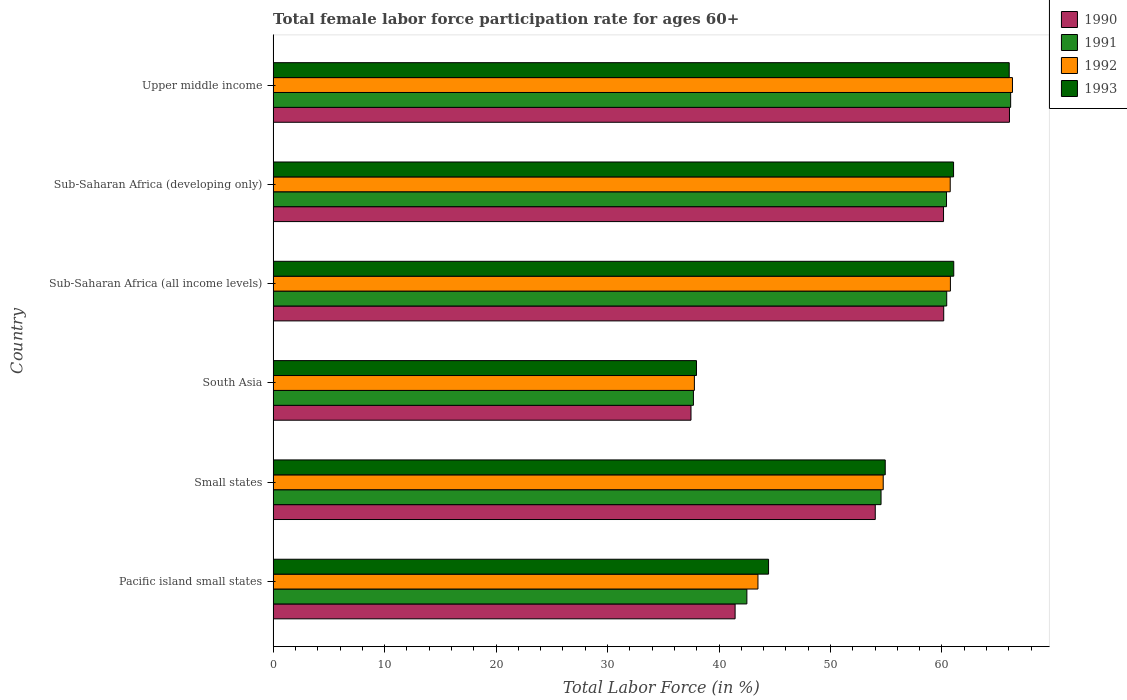How many different coloured bars are there?
Make the answer very short. 4. Are the number of bars per tick equal to the number of legend labels?
Provide a short and direct response. Yes. How many bars are there on the 2nd tick from the bottom?
Keep it short and to the point. 4. What is the label of the 1st group of bars from the top?
Give a very brief answer. Upper middle income. What is the female labor force participation rate in 1993 in South Asia?
Ensure brevity in your answer.  37.98. Across all countries, what is the maximum female labor force participation rate in 1990?
Ensure brevity in your answer.  66.05. Across all countries, what is the minimum female labor force participation rate in 1993?
Offer a terse response. 37.98. In which country was the female labor force participation rate in 1991 maximum?
Provide a short and direct response. Upper middle income. What is the total female labor force participation rate in 1992 in the graph?
Ensure brevity in your answer.  323.83. What is the difference between the female labor force participation rate in 1992 in Sub-Saharan Africa (developing only) and that in Upper middle income?
Keep it short and to the point. -5.58. What is the difference between the female labor force participation rate in 1992 in Pacific island small states and the female labor force participation rate in 1993 in South Asia?
Your answer should be compact. 5.51. What is the average female labor force participation rate in 1993 per country?
Give a very brief answer. 54.24. What is the difference between the female labor force participation rate in 1990 and female labor force participation rate in 1992 in Pacific island small states?
Your response must be concise. -2.05. What is the ratio of the female labor force participation rate in 1990 in Pacific island small states to that in Small states?
Keep it short and to the point. 0.77. Is the female labor force participation rate in 1991 in Sub-Saharan Africa (developing only) less than that in Upper middle income?
Your response must be concise. Yes. Is the difference between the female labor force participation rate in 1990 in Pacific island small states and South Asia greater than the difference between the female labor force participation rate in 1992 in Pacific island small states and South Asia?
Give a very brief answer. No. What is the difference between the highest and the second highest female labor force participation rate in 1991?
Your answer should be very brief. 5.74. What is the difference between the highest and the lowest female labor force participation rate in 1991?
Ensure brevity in your answer.  28.46. In how many countries, is the female labor force participation rate in 1993 greater than the average female labor force participation rate in 1993 taken over all countries?
Provide a succinct answer. 4. Is the sum of the female labor force participation rate in 1992 in Sub-Saharan Africa (all income levels) and Sub-Saharan Africa (developing only) greater than the maximum female labor force participation rate in 1991 across all countries?
Give a very brief answer. Yes. What does the 1st bar from the bottom in Sub-Saharan Africa (developing only) represents?
Give a very brief answer. 1990. Is it the case that in every country, the sum of the female labor force participation rate in 1991 and female labor force participation rate in 1993 is greater than the female labor force participation rate in 1992?
Provide a short and direct response. Yes. How many countries are there in the graph?
Provide a succinct answer. 6. What is the difference between two consecutive major ticks on the X-axis?
Keep it short and to the point. 10. Are the values on the major ticks of X-axis written in scientific E-notation?
Offer a terse response. No. Does the graph contain grids?
Offer a terse response. No. Where does the legend appear in the graph?
Give a very brief answer. Top right. How many legend labels are there?
Keep it short and to the point. 4. What is the title of the graph?
Give a very brief answer. Total female labor force participation rate for ages 60+. What is the Total Labor Force (in %) of 1990 in Pacific island small states?
Offer a very short reply. 41.44. What is the Total Labor Force (in %) in 1991 in Pacific island small states?
Give a very brief answer. 42.5. What is the Total Labor Force (in %) of 1992 in Pacific island small states?
Keep it short and to the point. 43.49. What is the Total Labor Force (in %) in 1993 in Pacific island small states?
Provide a succinct answer. 44.44. What is the Total Labor Force (in %) in 1990 in Small states?
Give a very brief answer. 54.02. What is the Total Labor Force (in %) in 1991 in Small states?
Your answer should be very brief. 54.53. What is the Total Labor Force (in %) of 1992 in Small states?
Ensure brevity in your answer.  54.73. What is the Total Labor Force (in %) of 1993 in Small states?
Your answer should be very brief. 54.91. What is the Total Labor Force (in %) of 1990 in South Asia?
Your answer should be compact. 37.49. What is the Total Labor Force (in %) of 1991 in South Asia?
Offer a very short reply. 37.7. What is the Total Labor Force (in %) in 1992 in South Asia?
Your answer should be very brief. 37.79. What is the Total Labor Force (in %) of 1993 in South Asia?
Your response must be concise. 37.98. What is the Total Labor Force (in %) of 1990 in Sub-Saharan Africa (all income levels)?
Provide a short and direct response. 60.16. What is the Total Labor Force (in %) in 1991 in Sub-Saharan Africa (all income levels)?
Provide a succinct answer. 60.42. What is the Total Labor Force (in %) of 1992 in Sub-Saharan Africa (all income levels)?
Provide a short and direct response. 60.76. What is the Total Labor Force (in %) in 1993 in Sub-Saharan Africa (all income levels)?
Give a very brief answer. 61.06. What is the Total Labor Force (in %) of 1990 in Sub-Saharan Africa (developing only)?
Offer a terse response. 60.14. What is the Total Labor Force (in %) in 1991 in Sub-Saharan Africa (developing only)?
Give a very brief answer. 60.41. What is the Total Labor Force (in %) of 1992 in Sub-Saharan Africa (developing only)?
Offer a very short reply. 60.74. What is the Total Labor Force (in %) in 1993 in Sub-Saharan Africa (developing only)?
Keep it short and to the point. 61.04. What is the Total Labor Force (in %) in 1990 in Upper middle income?
Provide a short and direct response. 66.05. What is the Total Labor Force (in %) of 1991 in Upper middle income?
Your answer should be very brief. 66.16. What is the Total Labor Force (in %) in 1992 in Upper middle income?
Make the answer very short. 66.32. What is the Total Labor Force (in %) of 1993 in Upper middle income?
Ensure brevity in your answer.  66.03. Across all countries, what is the maximum Total Labor Force (in %) of 1990?
Ensure brevity in your answer.  66.05. Across all countries, what is the maximum Total Labor Force (in %) of 1991?
Provide a short and direct response. 66.16. Across all countries, what is the maximum Total Labor Force (in %) of 1992?
Your answer should be compact. 66.32. Across all countries, what is the maximum Total Labor Force (in %) in 1993?
Offer a terse response. 66.03. Across all countries, what is the minimum Total Labor Force (in %) of 1990?
Ensure brevity in your answer.  37.49. Across all countries, what is the minimum Total Labor Force (in %) in 1991?
Ensure brevity in your answer.  37.7. Across all countries, what is the minimum Total Labor Force (in %) in 1992?
Offer a terse response. 37.79. Across all countries, what is the minimum Total Labor Force (in %) in 1993?
Ensure brevity in your answer.  37.98. What is the total Total Labor Force (in %) in 1990 in the graph?
Offer a terse response. 319.3. What is the total Total Labor Force (in %) of 1991 in the graph?
Offer a very short reply. 321.73. What is the total Total Labor Force (in %) of 1992 in the graph?
Give a very brief answer. 323.83. What is the total Total Labor Force (in %) of 1993 in the graph?
Your answer should be very brief. 325.46. What is the difference between the Total Labor Force (in %) of 1990 in Pacific island small states and that in Small states?
Give a very brief answer. -12.57. What is the difference between the Total Labor Force (in %) of 1991 in Pacific island small states and that in Small states?
Your answer should be very brief. -12.04. What is the difference between the Total Labor Force (in %) of 1992 in Pacific island small states and that in Small states?
Your answer should be very brief. -11.24. What is the difference between the Total Labor Force (in %) in 1993 in Pacific island small states and that in Small states?
Your answer should be very brief. -10.47. What is the difference between the Total Labor Force (in %) in 1990 in Pacific island small states and that in South Asia?
Keep it short and to the point. 3.96. What is the difference between the Total Labor Force (in %) in 1991 in Pacific island small states and that in South Asia?
Give a very brief answer. 4.79. What is the difference between the Total Labor Force (in %) in 1992 in Pacific island small states and that in South Asia?
Keep it short and to the point. 5.7. What is the difference between the Total Labor Force (in %) of 1993 in Pacific island small states and that in South Asia?
Offer a terse response. 6.47. What is the difference between the Total Labor Force (in %) of 1990 in Pacific island small states and that in Sub-Saharan Africa (all income levels)?
Provide a short and direct response. -18.71. What is the difference between the Total Labor Force (in %) in 1991 in Pacific island small states and that in Sub-Saharan Africa (all income levels)?
Provide a short and direct response. -17.93. What is the difference between the Total Labor Force (in %) of 1992 in Pacific island small states and that in Sub-Saharan Africa (all income levels)?
Provide a short and direct response. -17.27. What is the difference between the Total Labor Force (in %) of 1993 in Pacific island small states and that in Sub-Saharan Africa (all income levels)?
Give a very brief answer. -16.61. What is the difference between the Total Labor Force (in %) of 1990 in Pacific island small states and that in Sub-Saharan Africa (developing only)?
Keep it short and to the point. -18.7. What is the difference between the Total Labor Force (in %) in 1991 in Pacific island small states and that in Sub-Saharan Africa (developing only)?
Your response must be concise. -17.91. What is the difference between the Total Labor Force (in %) of 1992 in Pacific island small states and that in Sub-Saharan Africa (developing only)?
Keep it short and to the point. -17.25. What is the difference between the Total Labor Force (in %) of 1993 in Pacific island small states and that in Sub-Saharan Africa (developing only)?
Your response must be concise. -16.6. What is the difference between the Total Labor Force (in %) of 1990 in Pacific island small states and that in Upper middle income?
Make the answer very short. -24.61. What is the difference between the Total Labor Force (in %) in 1991 in Pacific island small states and that in Upper middle income?
Ensure brevity in your answer.  -23.66. What is the difference between the Total Labor Force (in %) in 1992 in Pacific island small states and that in Upper middle income?
Your answer should be very brief. -22.83. What is the difference between the Total Labor Force (in %) in 1993 in Pacific island small states and that in Upper middle income?
Your answer should be compact. -21.59. What is the difference between the Total Labor Force (in %) of 1990 in Small states and that in South Asia?
Offer a very short reply. 16.53. What is the difference between the Total Labor Force (in %) in 1991 in Small states and that in South Asia?
Offer a terse response. 16.83. What is the difference between the Total Labor Force (in %) of 1992 in Small states and that in South Asia?
Your answer should be very brief. 16.94. What is the difference between the Total Labor Force (in %) in 1993 in Small states and that in South Asia?
Keep it short and to the point. 16.93. What is the difference between the Total Labor Force (in %) in 1990 in Small states and that in Sub-Saharan Africa (all income levels)?
Give a very brief answer. -6.14. What is the difference between the Total Labor Force (in %) in 1991 in Small states and that in Sub-Saharan Africa (all income levels)?
Make the answer very short. -5.89. What is the difference between the Total Labor Force (in %) in 1992 in Small states and that in Sub-Saharan Africa (all income levels)?
Provide a short and direct response. -6.03. What is the difference between the Total Labor Force (in %) of 1993 in Small states and that in Sub-Saharan Africa (all income levels)?
Offer a terse response. -6.15. What is the difference between the Total Labor Force (in %) of 1990 in Small states and that in Sub-Saharan Africa (developing only)?
Give a very brief answer. -6.12. What is the difference between the Total Labor Force (in %) of 1991 in Small states and that in Sub-Saharan Africa (developing only)?
Give a very brief answer. -5.87. What is the difference between the Total Labor Force (in %) of 1992 in Small states and that in Sub-Saharan Africa (developing only)?
Offer a very short reply. -6.01. What is the difference between the Total Labor Force (in %) of 1993 in Small states and that in Sub-Saharan Africa (developing only)?
Your response must be concise. -6.13. What is the difference between the Total Labor Force (in %) in 1990 in Small states and that in Upper middle income?
Offer a very short reply. -12.04. What is the difference between the Total Labor Force (in %) of 1991 in Small states and that in Upper middle income?
Offer a very short reply. -11.63. What is the difference between the Total Labor Force (in %) of 1992 in Small states and that in Upper middle income?
Provide a short and direct response. -11.59. What is the difference between the Total Labor Force (in %) of 1993 in Small states and that in Upper middle income?
Give a very brief answer. -11.12. What is the difference between the Total Labor Force (in %) of 1990 in South Asia and that in Sub-Saharan Africa (all income levels)?
Offer a very short reply. -22.67. What is the difference between the Total Labor Force (in %) in 1991 in South Asia and that in Sub-Saharan Africa (all income levels)?
Give a very brief answer. -22.72. What is the difference between the Total Labor Force (in %) of 1992 in South Asia and that in Sub-Saharan Africa (all income levels)?
Give a very brief answer. -22.97. What is the difference between the Total Labor Force (in %) in 1993 in South Asia and that in Sub-Saharan Africa (all income levels)?
Provide a succinct answer. -23.08. What is the difference between the Total Labor Force (in %) of 1990 in South Asia and that in Sub-Saharan Africa (developing only)?
Provide a succinct answer. -22.65. What is the difference between the Total Labor Force (in %) of 1991 in South Asia and that in Sub-Saharan Africa (developing only)?
Give a very brief answer. -22.7. What is the difference between the Total Labor Force (in %) in 1992 in South Asia and that in Sub-Saharan Africa (developing only)?
Offer a terse response. -22.95. What is the difference between the Total Labor Force (in %) of 1993 in South Asia and that in Sub-Saharan Africa (developing only)?
Offer a very short reply. -23.06. What is the difference between the Total Labor Force (in %) of 1990 in South Asia and that in Upper middle income?
Your answer should be compact. -28.57. What is the difference between the Total Labor Force (in %) of 1991 in South Asia and that in Upper middle income?
Provide a succinct answer. -28.46. What is the difference between the Total Labor Force (in %) in 1992 in South Asia and that in Upper middle income?
Keep it short and to the point. -28.53. What is the difference between the Total Labor Force (in %) in 1993 in South Asia and that in Upper middle income?
Offer a terse response. -28.05. What is the difference between the Total Labor Force (in %) in 1990 in Sub-Saharan Africa (all income levels) and that in Sub-Saharan Africa (developing only)?
Ensure brevity in your answer.  0.02. What is the difference between the Total Labor Force (in %) in 1991 in Sub-Saharan Africa (all income levels) and that in Sub-Saharan Africa (developing only)?
Your answer should be compact. 0.02. What is the difference between the Total Labor Force (in %) in 1992 in Sub-Saharan Africa (all income levels) and that in Sub-Saharan Africa (developing only)?
Your response must be concise. 0.02. What is the difference between the Total Labor Force (in %) in 1993 in Sub-Saharan Africa (all income levels) and that in Sub-Saharan Africa (developing only)?
Provide a succinct answer. 0.02. What is the difference between the Total Labor Force (in %) in 1990 in Sub-Saharan Africa (all income levels) and that in Upper middle income?
Your answer should be compact. -5.9. What is the difference between the Total Labor Force (in %) of 1991 in Sub-Saharan Africa (all income levels) and that in Upper middle income?
Give a very brief answer. -5.74. What is the difference between the Total Labor Force (in %) in 1992 in Sub-Saharan Africa (all income levels) and that in Upper middle income?
Ensure brevity in your answer.  -5.57. What is the difference between the Total Labor Force (in %) in 1993 in Sub-Saharan Africa (all income levels) and that in Upper middle income?
Give a very brief answer. -4.98. What is the difference between the Total Labor Force (in %) in 1990 in Sub-Saharan Africa (developing only) and that in Upper middle income?
Give a very brief answer. -5.92. What is the difference between the Total Labor Force (in %) of 1991 in Sub-Saharan Africa (developing only) and that in Upper middle income?
Provide a short and direct response. -5.75. What is the difference between the Total Labor Force (in %) of 1992 in Sub-Saharan Africa (developing only) and that in Upper middle income?
Give a very brief answer. -5.58. What is the difference between the Total Labor Force (in %) of 1993 in Sub-Saharan Africa (developing only) and that in Upper middle income?
Your answer should be compact. -4.99. What is the difference between the Total Labor Force (in %) of 1990 in Pacific island small states and the Total Labor Force (in %) of 1991 in Small states?
Keep it short and to the point. -13.09. What is the difference between the Total Labor Force (in %) of 1990 in Pacific island small states and the Total Labor Force (in %) of 1992 in Small states?
Offer a terse response. -13.29. What is the difference between the Total Labor Force (in %) in 1990 in Pacific island small states and the Total Labor Force (in %) in 1993 in Small states?
Give a very brief answer. -13.47. What is the difference between the Total Labor Force (in %) of 1991 in Pacific island small states and the Total Labor Force (in %) of 1992 in Small states?
Make the answer very short. -12.23. What is the difference between the Total Labor Force (in %) of 1991 in Pacific island small states and the Total Labor Force (in %) of 1993 in Small states?
Keep it short and to the point. -12.41. What is the difference between the Total Labor Force (in %) in 1992 in Pacific island small states and the Total Labor Force (in %) in 1993 in Small states?
Your response must be concise. -11.42. What is the difference between the Total Labor Force (in %) in 1990 in Pacific island small states and the Total Labor Force (in %) in 1991 in South Asia?
Your answer should be compact. 3.74. What is the difference between the Total Labor Force (in %) in 1990 in Pacific island small states and the Total Labor Force (in %) in 1992 in South Asia?
Provide a short and direct response. 3.65. What is the difference between the Total Labor Force (in %) of 1990 in Pacific island small states and the Total Labor Force (in %) of 1993 in South Asia?
Your answer should be compact. 3.46. What is the difference between the Total Labor Force (in %) of 1991 in Pacific island small states and the Total Labor Force (in %) of 1992 in South Asia?
Your response must be concise. 4.71. What is the difference between the Total Labor Force (in %) in 1991 in Pacific island small states and the Total Labor Force (in %) in 1993 in South Asia?
Your answer should be compact. 4.52. What is the difference between the Total Labor Force (in %) of 1992 in Pacific island small states and the Total Labor Force (in %) of 1993 in South Asia?
Your answer should be compact. 5.51. What is the difference between the Total Labor Force (in %) of 1990 in Pacific island small states and the Total Labor Force (in %) of 1991 in Sub-Saharan Africa (all income levels)?
Keep it short and to the point. -18.98. What is the difference between the Total Labor Force (in %) of 1990 in Pacific island small states and the Total Labor Force (in %) of 1992 in Sub-Saharan Africa (all income levels)?
Offer a very short reply. -19.31. What is the difference between the Total Labor Force (in %) in 1990 in Pacific island small states and the Total Labor Force (in %) in 1993 in Sub-Saharan Africa (all income levels)?
Keep it short and to the point. -19.61. What is the difference between the Total Labor Force (in %) in 1991 in Pacific island small states and the Total Labor Force (in %) in 1992 in Sub-Saharan Africa (all income levels)?
Provide a succinct answer. -18.26. What is the difference between the Total Labor Force (in %) in 1991 in Pacific island small states and the Total Labor Force (in %) in 1993 in Sub-Saharan Africa (all income levels)?
Provide a short and direct response. -18.56. What is the difference between the Total Labor Force (in %) in 1992 in Pacific island small states and the Total Labor Force (in %) in 1993 in Sub-Saharan Africa (all income levels)?
Your answer should be very brief. -17.56. What is the difference between the Total Labor Force (in %) in 1990 in Pacific island small states and the Total Labor Force (in %) in 1991 in Sub-Saharan Africa (developing only)?
Ensure brevity in your answer.  -18.96. What is the difference between the Total Labor Force (in %) in 1990 in Pacific island small states and the Total Labor Force (in %) in 1992 in Sub-Saharan Africa (developing only)?
Offer a terse response. -19.3. What is the difference between the Total Labor Force (in %) of 1990 in Pacific island small states and the Total Labor Force (in %) of 1993 in Sub-Saharan Africa (developing only)?
Provide a succinct answer. -19.6. What is the difference between the Total Labor Force (in %) of 1991 in Pacific island small states and the Total Labor Force (in %) of 1992 in Sub-Saharan Africa (developing only)?
Make the answer very short. -18.24. What is the difference between the Total Labor Force (in %) of 1991 in Pacific island small states and the Total Labor Force (in %) of 1993 in Sub-Saharan Africa (developing only)?
Your answer should be compact. -18.54. What is the difference between the Total Labor Force (in %) of 1992 in Pacific island small states and the Total Labor Force (in %) of 1993 in Sub-Saharan Africa (developing only)?
Make the answer very short. -17.55. What is the difference between the Total Labor Force (in %) in 1990 in Pacific island small states and the Total Labor Force (in %) in 1991 in Upper middle income?
Give a very brief answer. -24.72. What is the difference between the Total Labor Force (in %) in 1990 in Pacific island small states and the Total Labor Force (in %) in 1992 in Upper middle income?
Make the answer very short. -24.88. What is the difference between the Total Labor Force (in %) of 1990 in Pacific island small states and the Total Labor Force (in %) of 1993 in Upper middle income?
Provide a short and direct response. -24.59. What is the difference between the Total Labor Force (in %) of 1991 in Pacific island small states and the Total Labor Force (in %) of 1992 in Upper middle income?
Your response must be concise. -23.83. What is the difference between the Total Labor Force (in %) of 1991 in Pacific island small states and the Total Labor Force (in %) of 1993 in Upper middle income?
Keep it short and to the point. -23.53. What is the difference between the Total Labor Force (in %) of 1992 in Pacific island small states and the Total Labor Force (in %) of 1993 in Upper middle income?
Your answer should be very brief. -22.54. What is the difference between the Total Labor Force (in %) in 1990 in Small states and the Total Labor Force (in %) in 1991 in South Asia?
Ensure brevity in your answer.  16.31. What is the difference between the Total Labor Force (in %) in 1990 in Small states and the Total Labor Force (in %) in 1992 in South Asia?
Offer a terse response. 16.23. What is the difference between the Total Labor Force (in %) in 1990 in Small states and the Total Labor Force (in %) in 1993 in South Asia?
Provide a succinct answer. 16.04. What is the difference between the Total Labor Force (in %) of 1991 in Small states and the Total Labor Force (in %) of 1992 in South Asia?
Ensure brevity in your answer.  16.74. What is the difference between the Total Labor Force (in %) of 1991 in Small states and the Total Labor Force (in %) of 1993 in South Asia?
Make the answer very short. 16.56. What is the difference between the Total Labor Force (in %) of 1992 in Small states and the Total Labor Force (in %) of 1993 in South Asia?
Your answer should be compact. 16.75. What is the difference between the Total Labor Force (in %) of 1990 in Small states and the Total Labor Force (in %) of 1991 in Sub-Saharan Africa (all income levels)?
Ensure brevity in your answer.  -6.41. What is the difference between the Total Labor Force (in %) in 1990 in Small states and the Total Labor Force (in %) in 1992 in Sub-Saharan Africa (all income levels)?
Offer a very short reply. -6.74. What is the difference between the Total Labor Force (in %) of 1990 in Small states and the Total Labor Force (in %) of 1993 in Sub-Saharan Africa (all income levels)?
Offer a very short reply. -7.04. What is the difference between the Total Labor Force (in %) of 1991 in Small states and the Total Labor Force (in %) of 1992 in Sub-Saharan Africa (all income levels)?
Provide a short and direct response. -6.22. What is the difference between the Total Labor Force (in %) in 1991 in Small states and the Total Labor Force (in %) in 1993 in Sub-Saharan Africa (all income levels)?
Give a very brief answer. -6.52. What is the difference between the Total Labor Force (in %) in 1992 in Small states and the Total Labor Force (in %) in 1993 in Sub-Saharan Africa (all income levels)?
Offer a terse response. -6.33. What is the difference between the Total Labor Force (in %) in 1990 in Small states and the Total Labor Force (in %) in 1991 in Sub-Saharan Africa (developing only)?
Provide a succinct answer. -6.39. What is the difference between the Total Labor Force (in %) in 1990 in Small states and the Total Labor Force (in %) in 1992 in Sub-Saharan Africa (developing only)?
Your response must be concise. -6.72. What is the difference between the Total Labor Force (in %) in 1990 in Small states and the Total Labor Force (in %) in 1993 in Sub-Saharan Africa (developing only)?
Provide a short and direct response. -7.02. What is the difference between the Total Labor Force (in %) in 1991 in Small states and the Total Labor Force (in %) in 1992 in Sub-Saharan Africa (developing only)?
Keep it short and to the point. -6.21. What is the difference between the Total Labor Force (in %) of 1991 in Small states and the Total Labor Force (in %) of 1993 in Sub-Saharan Africa (developing only)?
Your answer should be compact. -6.5. What is the difference between the Total Labor Force (in %) in 1992 in Small states and the Total Labor Force (in %) in 1993 in Sub-Saharan Africa (developing only)?
Make the answer very short. -6.31. What is the difference between the Total Labor Force (in %) in 1990 in Small states and the Total Labor Force (in %) in 1991 in Upper middle income?
Make the answer very short. -12.15. What is the difference between the Total Labor Force (in %) of 1990 in Small states and the Total Labor Force (in %) of 1992 in Upper middle income?
Your answer should be very brief. -12.31. What is the difference between the Total Labor Force (in %) of 1990 in Small states and the Total Labor Force (in %) of 1993 in Upper middle income?
Your answer should be very brief. -12.02. What is the difference between the Total Labor Force (in %) in 1991 in Small states and the Total Labor Force (in %) in 1992 in Upper middle income?
Give a very brief answer. -11.79. What is the difference between the Total Labor Force (in %) of 1991 in Small states and the Total Labor Force (in %) of 1993 in Upper middle income?
Offer a very short reply. -11.5. What is the difference between the Total Labor Force (in %) in 1992 in Small states and the Total Labor Force (in %) in 1993 in Upper middle income?
Give a very brief answer. -11.3. What is the difference between the Total Labor Force (in %) in 1990 in South Asia and the Total Labor Force (in %) in 1991 in Sub-Saharan Africa (all income levels)?
Ensure brevity in your answer.  -22.94. What is the difference between the Total Labor Force (in %) in 1990 in South Asia and the Total Labor Force (in %) in 1992 in Sub-Saharan Africa (all income levels)?
Ensure brevity in your answer.  -23.27. What is the difference between the Total Labor Force (in %) in 1990 in South Asia and the Total Labor Force (in %) in 1993 in Sub-Saharan Africa (all income levels)?
Your answer should be compact. -23.57. What is the difference between the Total Labor Force (in %) in 1991 in South Asia and the Total Labor Force (in %) in 1992 in Sub-Saharan Africa (all income levels)?
Offer a very short reply. -23.05. What is the difference between the Total Labor Force (in %) of 1991 in South Asia and the Total Labor Force (in %) of 1993 in Sub-Saharan Africa (all income levels)?
Ensure brevity in your answer.  -23.35. What is the difference between the Total Labor Force (in %) in 1992 in South Asia and the Total Labor Force (in %) in 1993 in Sub-Saharan Africa (all income levels)?
Ensure brevity in your answer.  -23.27. What is the difference between the Total Labor Force (in %) in 1990 in South Asia and the Total Labor Force (in %) in 1991 in Sub-Saharan Africa (developing only)?
Make the answer very short. -22.92. What is the difference between the Total Labor Force (in %) in 1990 in South Asia and the Total Labor Force (in %) in 1992 in Sub-Saharan Africa (developing only)?
Offer a very short reply. -23.25. What is the difference between the Total Labor Force (in %) in 1990 in South Asia and the Total Labor Force (in %) in 1993 in Sub-Saharan Africa (developing only)?
Keep it short and to the point. -23.55. What is the difference between the Total Labor Force (in %) in 1991 in South Asia and the Total Labor Force (in %) in 1992 in Sub-Saharan Africa (developing only)?
Ensure brevity in your answer.  -23.04. What is the difference between the Total Labor Force (in %) of 1991 in South Asia and the Total Labor Force (in %) of 1993 in Sub-Saharan Africa (developing only)?
Offer a terse response. -23.34. What is the difference between the Total Labor Force (in %) in 1992 in South Asia and the Total Labor Force (in %) in 1993 in Sub-Saharan Africa (developing only)?
Your answer should be compact. -23.25. What is the difference between the Total Labor Force (in %) of 1990 in South Asia and the Total Labor Force (in %) of 1991 in Upper middle income?
Your answer should be very brief. -28.67. What is the difference between the Total Labor Force (in %) in 1990 in South Asia and the Total Labor Force (in %) in 1992 in Upper middle income?
Offer a terse response. -28.84. What is the difference between the Total Labor Force (in %) in 1990 in South Asia and the Total Labor Force (in %) in 1993 in Upper middle income?
Make the answer very short. -28.55. What is the difference between the Total Labor Force (in %) in 1991 in South Asia and the Total Labor Force (in %) in 1992 in Upper middle income?
Your response must be concise. -28.62. What is the difference between the Total Labor Force (in %) in 1991 in South Asia and the Total Labor Force (in %) in 1993 in Upper middle income?
Provide a short and direct response. -28.33. What is the difference between the Total Labor Force (in %) in 1992 in South Asia and the Total Labor Force (in %) in 1993 in Upper middle income?
Keep it short and to the point. -28.24. What is the difference between the Total Labor Force (in %) in 1990 in Sub-Saharan Africa (all income levels) and the Total Labor Force (in %) in 1991 in Sub-Saharan Africa (developing only)?
Give a very brief answer. -0.25. What is the difference between the Total Labor Force (in %) in 1990 in Sub-Saharan Africa (all income levels) and the Total Labor Force (in %) in 1992 in Sub-Saharan Africa (developing only)?
Your answer should be compact. -0.58. What is the difference between the Total Labor Force (in %) of 1990 in Sub-Saharan Africa (all income levels) and the Total Labor Force (in %) of 1993 in Sub-Saharan Africa (developing only)?
Your answer should be very brief. -0.88. What is the difference between the Total Labor Force (in %) of 1991 in Sub-Saharan Africa (all income levels) and the Total Labor Force (in %) of 1992 in Sub-Saharan Africa (developing only)?
Keep it short and to the point. -0.31. What is the difference between the Total Labor Force (in %) in 1991 in Sub-Saharan Africa (all income levels) and the Total Labor Force (in %) in 1993 in Sub-Saharan Africa (developing only)?
Offer a terse response. -0.61. What is the difference between the Total Labor Force (in %) in 1992 in Sub-Saharan Africa (all income levels) and the Total Labor Force (in %) in 1993 in Sub-Saharan Africa (developing only)?
Give a very brief answer. -0.28. What is the difference between the Total Labor Force (in %) in 1990 in Sub-Saharan Africa (all income levels) and the Total Labor Force (in %) in 1991 in Upper middle income?
Ensure brevity in your answer.  -6. What is the difference between the Total Labor Force (in %) in 1990 in Sub-Saharan Africa (all income levels) and the Total Labor Force (in %) in 1992 in Upper middle income?
Your answer should be compact. -6.17. What is the difference between the Total Labor Force (in %) in 1990 in Sub-Saharan Africa (all income levels) and the Total Labor Force (in %) in 1993 in Upper middle income?
Offer a terse response. -5.88. What is the difference between the Total Labor Force (in %) in 1991 in Sub-Saharan Africa (all income levels) and the Total Labor Force (in %) in 1992 in Upper middle income?
Provide a succinct answer. -5.9. What is the difference between the Total Labor Force (in %) in 1991 in Sub-Saharan Africa (all income levels) and the Total Labor Force (in %) in 1993 in Upper middle income?
Offer a terse response. -5.61. What is the difference between the Total Labor Force (in %) of 1992 in Sub-Saharan Africa (all income levels) and the Total Labor Force (in %) of 1993 in Upper middle income?
Offer a very short reply. -5.28. What is the difference between the Total Labor Force (in %) of 1990 in Sub-Saharan Africa (developing only) and the Total Labor Force (in %) of 1991 in Upper middle income?
Provide a short and direct response. -6.02. What is the difference between the Total Labor Force (in %) of 1990 in Sub-Saharan Africa (developing only) and the Total Labor Force (in %) of 1992 in Upper middle income?
Your answer should be very brief. -6.18. What is the difference between the Total Labor Force (in %) in 1990 in Sub-Saharan Africa (developing only) and the Total Labor Force (in %) in 1993 in Upper middle income?
Your response must be concise. -5.89. What is the difference between the Total Labor Force (in %) of 1991 in Sub-Saharan Africa (developing only) and the Total Labor Force (in %) of 1992 in Upper middle income?
Keep it short and to the point. -5.92. What is the difference between the Total Labor Force (in %) of 1991 in Sub-Saharan Africa (developing only) and the Total Labor Force (in %) of 1993 in Upper middle income?
Offer a terse response. -5.63. What is the difference between the Total Labor Force (in %) of 1992 in Sub-Saharan Africa (developing only) and the Total Labor Force (in %) of 1993 in Upper middle income?
Ensure brevity in your answer.  -5.29. What is the average Total Labor Force (in %) of 1990 per country?
Keep it short and to the point. 53.22. What is the average Total Labor Force (in %) in 1991 per country?
Your answer should be compact. 53.62. What is the average Total Labor Force (in %) of 1992 per country?
Give a very brief answer. 53.97. What is the average Total Labor Force (in %) in 1993 per country?
Ensure brevity in your answer.  54.24. What is the difference between the Total Labor Force (in %) in 1990 and Total Labor Force (in %) in 1991 in Pacific island small states?
Give a very brief answer. -1.05. What is the difference between the Total Labor Force (in %) of 1990 and Total Labor Force (in %) of 1992 in Pacific island small states?
Provide a short and direct response. -2.05. What is the difference between the Total Labor Force (in %) of 1990 and Total Labor Force (in %) of 1993 in Pacific island small states?
Make the answer very short. -3. What is the difference between the Total Labor Force (in %) of 1991 and Total Labor Force (in %) of 1992 in Pacific island small states?
Provide a succinct answer. -0.99. What is the difference between the Total Labor Force (in %) in 1991 and Total Labor Force (in %) in 1993 in Pacific island small states?
Keep it short and to the point. -1.95. What is the difference between the Total Labor Force (in %) in 1992 and Total Labor Force (in %) in 1993 in Pacific island small states?
Offer a terse response. -0.95. What is the difference between the Total Labor Force (in %) of 1990 and Total Labor Force (in %) of 1991 in Small states?
Ensure brevity in your answer.  -0.52. What is the difference between the Total Labor Force (in %) in 1990 and Total Labor Force (in %) in 1992 in Small states?
Provide a succinct answer. -0.71. What is the difference between the Total Labor Force (in %) of 1990 and Total Labor Force (in %) of 1993 in Small states?
Ensure brevity in your answer.  -0.89. What is the difference between the Total Labor Force (in %) in 1991 and Total Labor Force (in %) in 1992 in Small states?
Make the answer very short. -0.19. What is the difference between the Total Labor Force (in %) of 1991 and Total Labor Force (in %) of 1993 in Small states?
Offer a very short reply. -0.38. What is the difference between the Total Labor Force (in %) in 1992 and Total Labor Force (in %) in 1993 in Small states?
Your response must be concise. -0.18. What is the difference between the Total Labor Force (in %) in 1990 and Total Labor Force (in %) in 1991 in South Asia?
Keep it short and to the point. -0.22. What is the difference between the Total Labor Force (in %) of 1990 and Total Labor Force (in %) of 1992 in South Asia?
Your answer should be very brief. -0.3. What is the difference between the Total Labor Force (in %) of 1990 and Total Labor Force (in %) of 1993 in South Asia?
Offer a very short reply. -0.49. What is the difference between the Total Labor Force (in %) in 1991 and Total Labor Force (in %) in 1992 in South Asia?
Offer a very short reply. -0.09. What is the difference between the Total Labor Force (in %) of 1991 and Total Labor Force (in %) of 1993 in South Asia?
Make the answer very short. -0.27. What is the difference between the Total Labor Force (in %) of 1992 and Total Labor Force (in %) of 1993 in South Asia?
Offer a very short reply. -0.19. What is the difference between the Total Labor Force (in %) of 1990 and Total Labor Force (in %) of 1991 in Sub-Saharan Africa (all income levels)?
Give a very brief answer. -0.27. What is the difference between the Total Labor Force (in %) in 1990 and Total Labor Force (in %) in 1992 in Sub-Saharan Africa (all income levels)?
Your answer should be compact. -0.6. What is the difference between the Total Labor Force (in %) in 1990 and Total Labor Force (in %) in 1993 in Sub-Saharan Africa (all income levels)?
Make the answer very short. -0.9. What is the difference between the Total Labor Force (in %) in 1991 and Total Labor Force (in %) in 1992 in Sub-Saharan Africa (all income levels)?
Give a very brief answer. -0.33. What is the difference between the Total Labor Force (in %) in 1991 and Total Labor Force (in %) in 1993 in Sub-Saharan Africa (all income levels)?
Provide a short and direct response. -0.63. What is the difference between the Total Labor Force (in %) in 1992 and Total Labor Force (in %) in 1993 in Sub-Saharan Africa (all income levels)?
Provide a succinct answer. -0.3. What is the difference between the Total Labor Force (in %) of 1990 and Total Labor Force (in %) of 1991 in Sub-Saharan Africa (developing only)?
Your response must be concise. -0.27. What is the difference between the Total Labor Force (in %) in 1990 and Total Labor Force (in %) in 1992 in Sub-Saharan Africa (developing only)?
Make the answer very short. -0.6. What is the difference between the Total Labor Force (in %) in 1990 and Total Labor Force (in %) in 1993 in Sub-Saharan Africa (developing only)?
Give a very brief answer. -0.9. What is the difference between the Total Labor Force (in %) of 1991 and Total Labor Force (in %) of 1992 in Sub-Saharan Africa (developing only)?
Your answer should be very brief. -0.33. What is the difference between the Total Labor Force (in %) in 1991 and Total Labor Force (in %) in 1993 in Sub-Saharan Africa (developing only)?
Provide a short and direct response. -0.63. What is the difference between the Total Labor Force (in %) of 1990 and Total Labor Force (in %) of 1991 in Upper middle income?
Provide a short and direct response. -0.11. What is the difference between the Total Labor Force (in %) in 1990 and Total Labor Force (in %) in 1992 in Upper middle income?
Ensure brevity in your answer.  -0.27. What is the difference between the Total Labor Force (in %) of 1990 and Total Labor Force (in %) of 1993 in Upper middle income?
Provide a succinct answer. 0.02. What is the difference between the Total Labor Force (in %) in 1991 and Total Labor Force (in %) in 1992 in Upper middle income?
Offer a terse response. -0.16. What is the difference between the Total Labor Force (in %) in 1991 and Total Labor Force (in %) in 1993 in Upper middle income?
Keep it short and to the point. 0.13. What is the difference between the Total Labor Force (in %) in 1992 and Total Labor Force (in %) in 1993 in Upper middle income?
Your answer should be compact. 0.29. What is the ratio of the Total Labor Force (in %) of 1990 in Pacific island small states to that in Small states?
Ensure brevity in your answer.  0.77. What is the ratio of the Total Labor Force (in %) in 1991 in Pacific island small states to that in Small states?
Keep it short and to the point. 0.78. What is the ratio of the Total Labor Force (in %) in 1992 in Pacific island small states to that in Small states?
Make the answer very short. 0.79. What is the ratio of the Total Labor Force (in %) in 1993 in Pacific island small states to that in Small states?
Provide a short and direct response. 0.81. What is the ratio of the Total Labor Force (in %) of 1990 in Pacific island small states to that in South Asia?
Your answer should be very brief. 1.11. What is the ratio of the Total Labor Force (in %) in 1991 in Pacific island small states to that in South Asia?
Your response must be concise. 1.13. What is the ratio of the Total Labor Force (in %) of 1992 in Pacific island small states to that in South Asia?
Provide a short and direct response. 1.15. What is the ratio of the Total Labor Force (in %) in 1993 in Pacific island small states to that in South Asia?
Your response must be concise. 1.17. What is the ratio of the Total Labor Force (in %) of 1990 in Pacific island small states to that in Sub-Saharan Africa (all income levels)?
Make the answer very short. 0.69. What is the ratio of the Total Labor Force (in %) of 1991 in Pacific island small states to that in Sub-Saharan Africa (all income levels)?
Provide a short and direct response. 0.7. What is the ratio of the Total Labor Force (in %) in 1992 in Pacific island small states to that in Sub-Saharan Africa (all income levels)?
Give a very brief answer. 0.72. What is the ratio of the Total Labor Force (in %) in 1993 in Pacific island small states to that in Sub-Saharan Africa (all income levels)?
Your response must be concise. 0.73. What is the ratio of the Total Labor Force (in %) of 1990 in Pacific island small states to that in Sub-Saharan Africa (developing only)?
Ensure brevity in your answer.  0.69. What is the ratio of the Total Labor Force (in %) of 1991 in Pacific island small states to that in Sub-Saharan Africa (developing only)?
Your response must be concise. 0.7. What is the ratio of the Total Labor Force (in %) of 1992 in Pacific island small states to that in Sub-Saharan Africa (developing only)?
Your response must be concise. 0.72. What is the ratio of the Total Labor Force (in %) of 1993 in Pacific island small states to that in Sub-Saharan Africa (developing only)?
Make the answer very short. 0.73. What is the ratio of the Total Labor Force (in %) in 1990 in Pacific island small states to that in Upper middle income?
Provide a short and direct response. 0.63. What is the ratio of the Total Labor Force (in %) in 1991 in Pacific island small states to that in Upper middle income?
Provide a succinct answer. 0.64. What is the ratio of the Total Labor Force (in %) in 1992 in Pacific island small states to that in Upper middle income?
Your response must be concise. 0.66. What is the ratio of the Total Labor Force (in %) of 1993 in Pacific island small states to that in Upper middle income?
Provide a short and direct response. 0.67. What is the ratio of the Total Labor Force (in %) in 1990 in Small states to that in South Asia?
Provide a succinct answer. 1.44. What is the ratio of the Total Labor Force (in %) in 1991 in Small states to that in South Asia?
Your answer should be very brief. 1.45. What is the ratio of the Total Labor Force (in %) in 1992 in Small states to that in South Asia?
Ensure brevity in your answer.  1.45. What is the ratio of the Total Labor Force (in %) of 1993 in Small states to that in South Asia?
Provide a succinct answer. 1.45. What is the ratio of the Total Labor Force (in %) of 1990 in Small states to that in Sub-Saharan Africa (all income levels)?
Your answer should be very brief. 0.9. What is the ratio of the Total Labor Force (in %) in 1991 in Small states to that in Sub-Saharan Africa (all income levels)?
Provide a succinct answer. 0.9. What is the ratio of the Total Labor Force (in %) of 1992 in Small states to that in Sub-Saharan Africa (all income levels)?
Give a very brief answer. 0.9. What is the ratio of the Total Labor Force (in %) in 1993 in Small states to that in Sub-Saharan Africa (all income levels)?
Provide a short and direct response. 0.9. What is the ratio of the Total Labor Force (in %) in 1990 in Small states to that in Sub-Saharan Africa (developing only)?
Your answer should be compact. 0.9. What is the ratio of the Total Labor Force (in %) in 1991 in Small states to that in Sub-Saharan Africa (developing only)?
Make the answer very short. 0.9. What is the ratio of the Total Labor Force (in %) of 1992 in Small states to that in Sub-Saharan Africa (developing only)?
Your answer should be compact. 0.9. What is the ratio of the Total Labor Force (in %) of 1993 in Small states to that in Sub-Saharan Africa (developing only)?
Make the answer very short. 0.9. What is the ratio of the Total Labor Force (in %) in 1990 in Small states to that in Upper middle income?
Keep it short and to the point. 0.82. What is the ratio of the Total Labor Force (in %) of 1991 in Small states to that in Upper middle income?
Provide a short and direct response. 0.82. What is the ratio of the Total Labor Force (in %) in 1992 in Small states to that in Upper middle income?
Make the answer very short. 0.83. What is the ratio of the Total Labor Force (in %) in 1993 in Small states to that in Upper middle income?
Provide a short and direct response. 0.83. What is the ratio of the Total Labor Force (in %) of 1990 in South Asia to that in Sub-Saharan Africa (all income levels)?
Provide a short and direct response. 0.62. What is the ratio of the Total Labor Force (in %) in 1991 in South Asia to that in Sub-Saharan Africa (all income levels)?
Ensure brevity in your answer.  0.62. What is the ratio of the Total Labor Force (in %) in 1992 in South Asia to that in Sub-Saharan Africa (all income levels)?
Your answer should be compact. 0.62. What is the ratio of the Total Labor Force (in %) of 1993 in South Asia to that in Sub-Saharan Africa (all income levels)?
Ensure brevity in your answer.  0.62. What is the ratio of the Total Labor Force (in %) in 1990 in South Asia to that in Sub-Saharan Africa (developing only)?
Offer a very short reply. 0.62. What is the ratio of the Total Labor Force (in %) of 1991 in South Asia to that in Sub-Saharan Africa (developing only)?
Your answer should be compact. 0.62. What is the ratio of the Total Labor Force (in %) of 1992 in South Asia to that in Sub-Saharan Africa (developing only)?
Ensure brevity in your answer.  0.62. What is the ratio of the Total Labor Force (in %) in 1993 in South Asia to that in Sub-Saharan Africa (developing only)?
Offer a very short reply. 0.62. What is the ratio of the Total Labor Force (in %) in 1990 in South Asia to that in Upper middle income?
Offer a terse response. 0.57. What is the ratio of the Total Labor Force (in %) of 1991 in South Asia to that in Upper middle income?
Your answer should be compact. 0.57. What is the ratio of the Total Labor Force (in %) of 1992 in South Asia to that in Upper middle income?
Give a very brief answer. 0.57. What is the ratio of the Total Labor Force (in %) in 1993 in South Asia to that in Upper middle income?
Your response must be concise. 0.58. What is the ratio of the Total Labor Force (in %) in 1991 in Sub-Saharan Africa (all income levels) to that in Sub-Saharan Africa (developing only)?
Your response must be concise. 1. What is the ratio of the Total Labor Force (in %) in 1992 in Sub-Saharan Africa (all income levels) to that in Sub-Saharan Africa (developing only)?
Provide a short and direct response. 1. What is the ratio of the Total Labor Force (in %) of 1993 in Sub-Saharan Africa (all income levels) to that in Sub-Saharan Africa (developing only)?
Offer a terse response. 1. What is the ratio of the Total Labor Force (in %) of 1990 in Sub-Saharan Africa (all income levels) to that in Upper middle income?
Ensure brevity in your answer.  0.91. What is the ratio of the Total Labor Force (in %) in 1991 in Sub-Saharan Africa (all income levels) to that in Upper middle income?
Your answer should be very brief. 0.91. What is the ratio of the Total Labor Force (in %) of 1992 in Sub-Saharan Africa (all income levels) to that in Upper middle income?
Give a very brief answer. 0.92. What is the ratio of the Total Labor Force (in %) in 1993 in Sub-Saharan Africa (all income levels) to that in Upper middle income?
Offer a terse response. 0.92. What is the ratio of the Total Labor Force (in %) in 1990 in Sub-Saharan Africa (developing only) to that in Upper middle income?
Offer a terse response. 0.91. What is the ratio of the Total Labor Force (in %) of 1992 in Sub-Saharan Africa (developing only) to that in Upper middle income?
Offer a terse response. 0.92. What is the ratio of the Total Labor Force (in %) in 1993 in Sub-Saharan Africa (developing only) to that in Upper middle income?
Give a very brief answer. 0.92. What is the difference between the highest and the second highest Total Labor Force (in %) of 1990?
Ensure brevity in your answer.  5.9. What is the difference between the highest and the second highest Total Labor Force (in %) of 1991?
Keep it short and to the point. 5.74. What is the difference between the highest and the second highest Total Labor Force (in %) of 1992?
Keep it short and to the point. 5.57. What is the difference between the highest and the second highest Total Labor Force (in %) of 1993?
Ensure brevity in your answer.  4.98. What is the difference between the highest and the lowest Total Labor Force (in %) of 1990?
Provide a short and direct response. 28.57. What is the difference between the highest and the lowest Total Labor Force (in %) in 1991?
Keep it short and to the point. 28.46. What is the difference between the highest and the lowest Total Labor Force (in %) in 1992?
Ensure brevity in your answer.  28.53. What is the difference between the highest and the lowest Total Labor Force (in %) in 1993?
Provide a succinct answer. 28.05. 